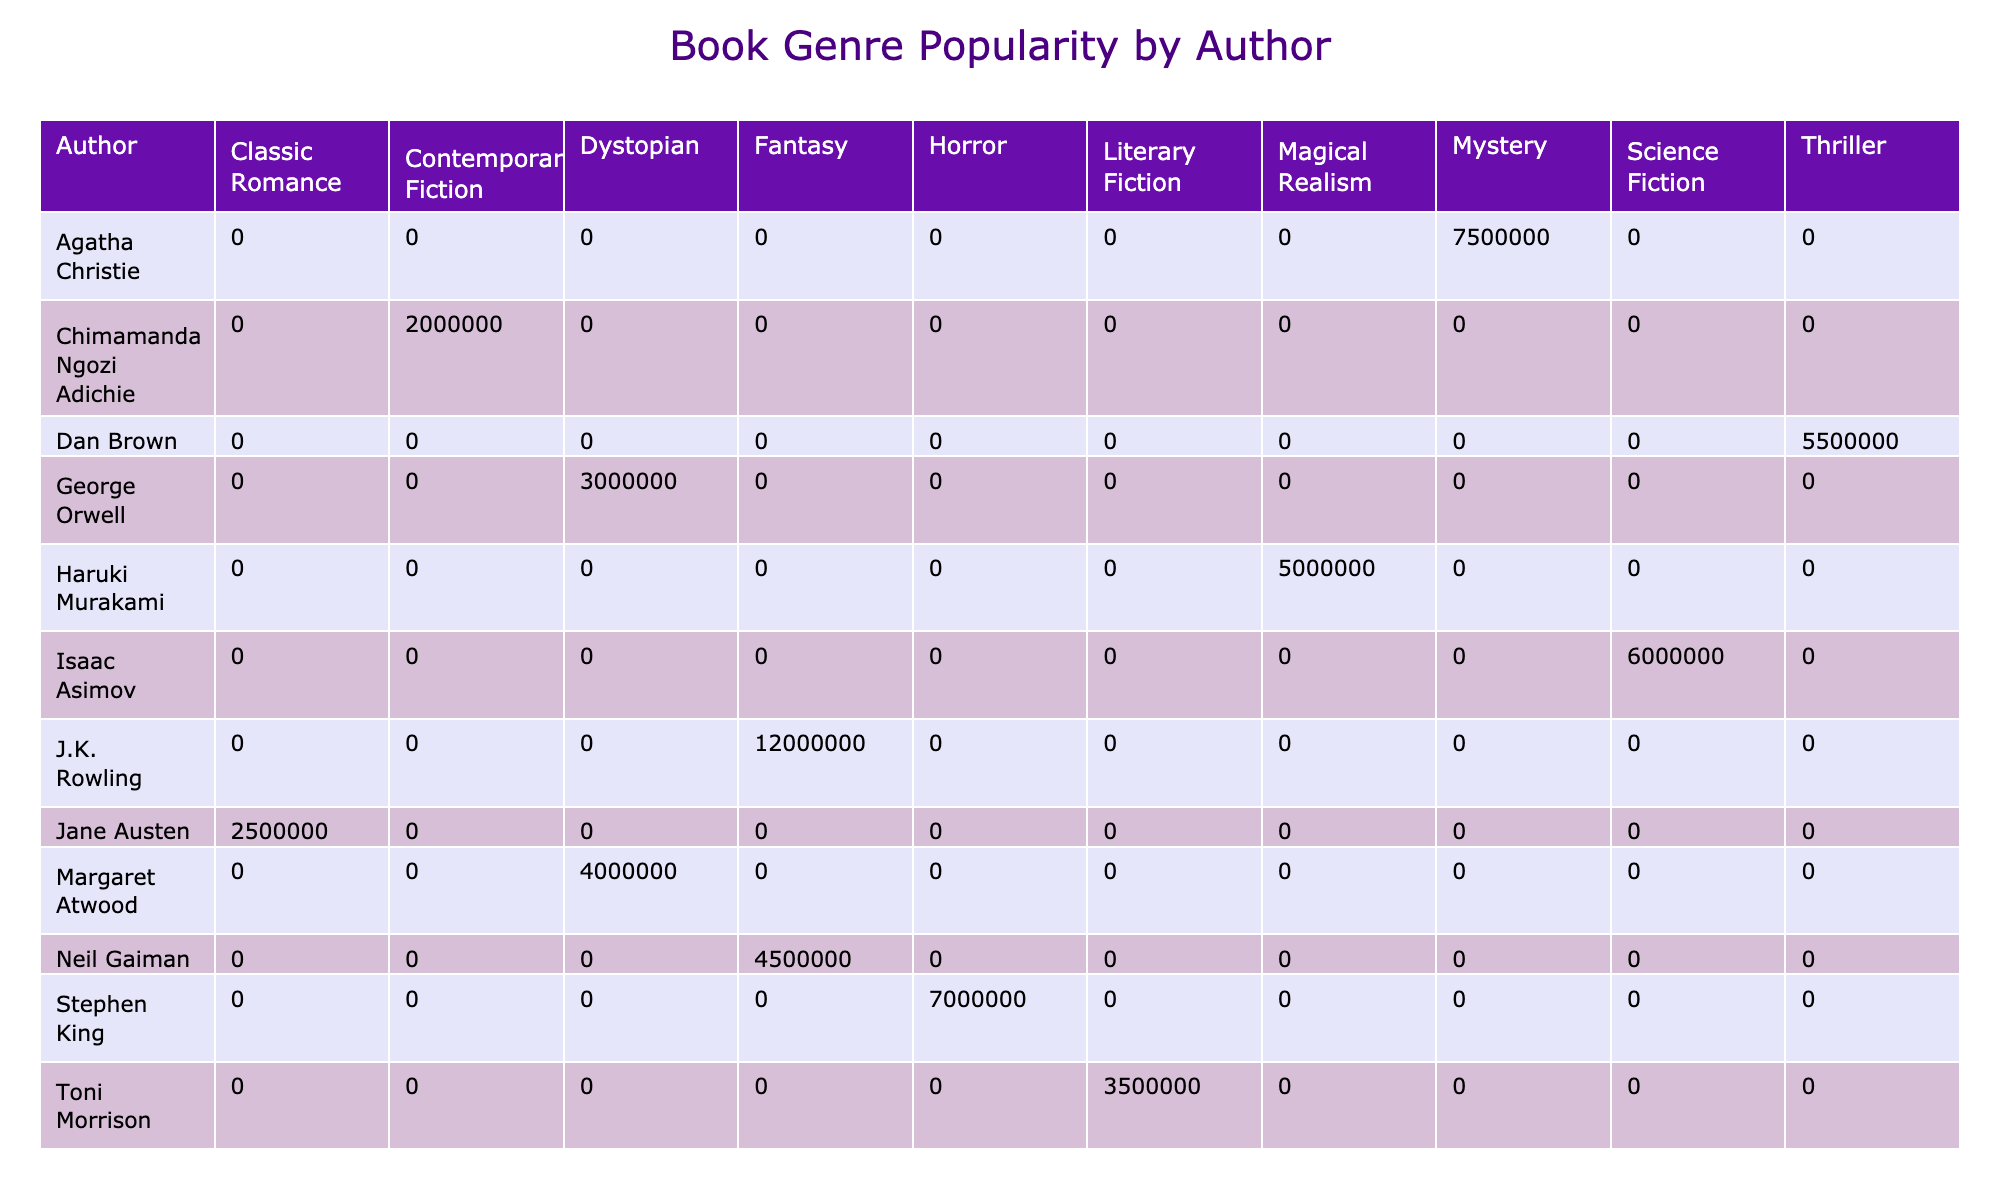What is the total number of books sold by J.K. Rowling? Referring to the table, J.K. Rowling sold 12,000,000 books under the genre Fantasy. This number represents the total sales attributed to this author in the given data.
Answer: 12,000,000 Which author sold more books, Stephen King or Agatha Christie? From the table, Stephen King sold 7,000,000 books, while Agatha Christie sold 7,500,000 books. Comparing these two values, Agatha Christie has higher sales than Stephen King.
Answer: Agatha Christie What is the total number of books sold across all authors in the Dystopian genre? The total for the Dystopian genre includes George Orwell with 3,000,000 and Margaret Atwood with 4,000,000. Adding these together gives us 3,000,000 + 4,000,000 = 7,000,000.
Answer: 7,000,000 Is Isaac Asimov the author with the highest book sales in any genre? Looking at the table, Isaac Asimov sold 6,000,000 books, which is not the highest as J.K. Rowling has 12,000,000 books sold in Fantasy. Thus, Isaac Asimov does not hold the highest sales in any genre.
Answer: No What is the difference in book sales between Agatha Christie and Dan Brown? From the table, Agatha Christie sold 7,500,000 books and Dan Brown sold 5,500,000 books. The difference is calculated by subtracting Dan Brown's sales from Agatha Christie's sales: 7,500,000 - 5,500,000 = 2,000,000.
Answer: 2,000,000 What percentage of total books sold belong to J.K. Rowling? First, sum the total books sold for all authors: 5,000,000 + 2,500,000 + 6,000,000 + 7,500,000 + 12,000,000 + 3,000,000 + 2,000,000 + 3,500,000 + 7,000,000 + 4,500,000 + 5,500,000 = 55,000,000. Then calculate the percentage: (12,000,000 / 55,000,000) * 100 ≈ 21.82%.
Answer: Approximately 21.82% Which genre has the least number of books sold collectively? By reviewing the book sales of each genre in the table, Contemporary Fiction by Chimamanda Ngozi Adichie has the lowest total with 2,000,000 as the only entry in this genre.
Answer: Contemporary Fiction Does any author have books sold in more than one genre? Looking at the data, each author appears only once in the table with a unique genre assigned to their sales. Therefore, no author has books sold in multiple genres in this dataset.
Answer: No Which genre has the highest total sales, and how much is it? To determine the highest total sales, calculate the sum of books sold for each genre. Fantasy is represented by two authors: J.K. Rowling with 12,000,000 and Neil Gaiman with 4,500,000; thus, total for Fantasy = 16,500,000. The next highest sales are from Agatha Christie in Mystery with 7,500,000. Therefore, Fantasy has the highest total sales.
Answer: Fantasy, 16,500,000 